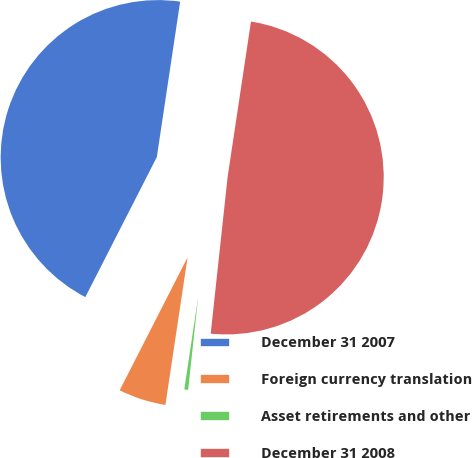Convert chart to OTSL. <chart><loc_0><loc_0><loc_500><loc_500><pie_chart><fcel>December 31 2007<fcel>Foreign currency translation<fcel>Asset retirements and other<fcel>December 31 2008<nl><fcel>44.86%<fcel>5.14%<fcel>0.66%<fcel>49.34%<nl></chart> 